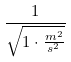<formula> <loc_0><loc_0><loc_500><loc_500>\frac { 1 } { \sqrt { 1 \cdot \frac { m ^ { 2 } } { s ^ { 2 } } } }</formula> 